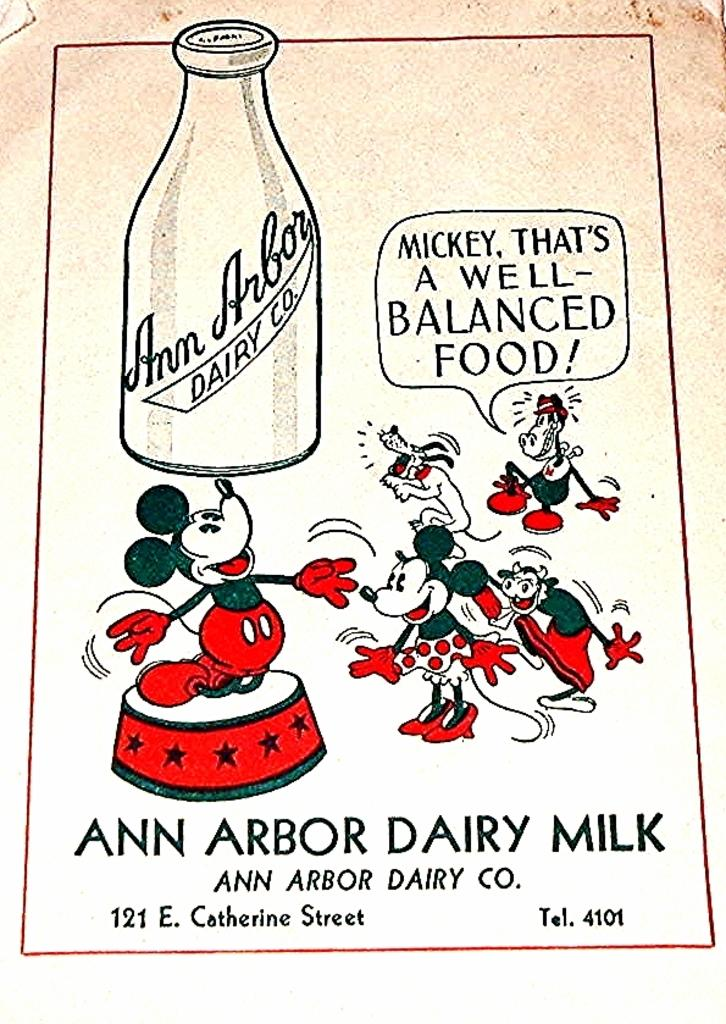What type of images are present in the picture? There are cartoon images in the picture. What object can be seen besides the cartoon images? There is a bottle in the picture. Is there any written content in the picture? Yes, there is text in the picture. Can you see a friend holding a gun in the downtown area in the picture? There is no friend, gun, or downtown area present in the picture; it contains cartoon images, a bottle, and text. 